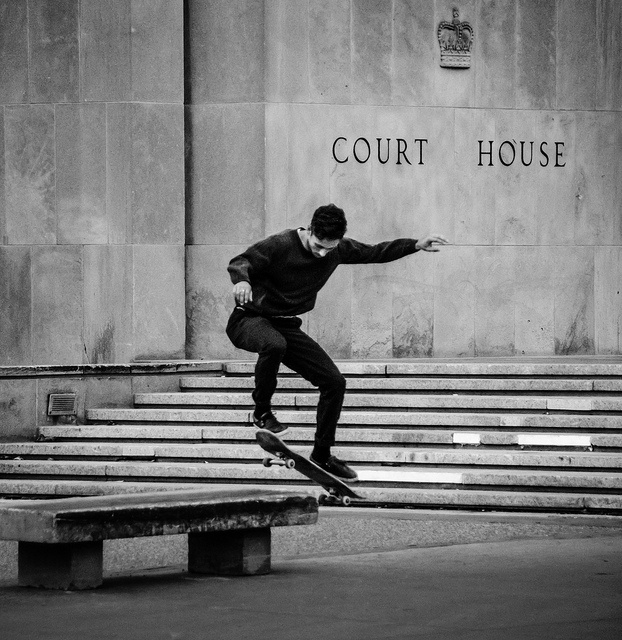Describe the objects in this image and their specific colors. I can see bench in gray, black, darkgray, and lightgray tones, people in gray, black, darkgray, and lightgray tones, and skateboard in gray, black, darkgray, and lightgray tones in this image. 